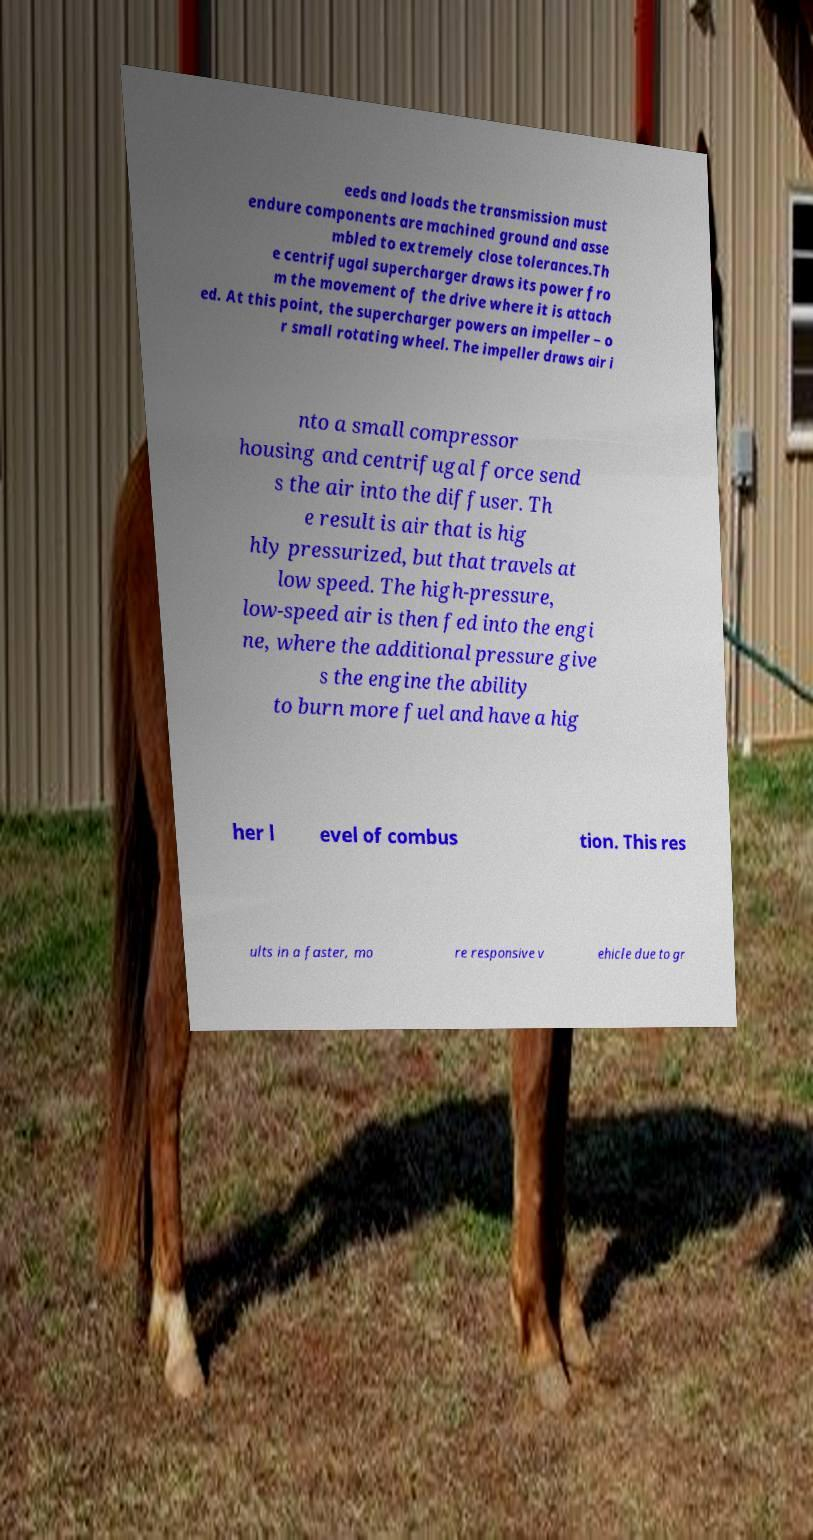Can you accurately transcribe the text from the provided image for me? eeds and loads the transmission must endure components are machined ground and asse mbled to extremely close tolerances.Th e centrifugal supercharger draws its power fro m the movement of the drive where it is attach ed. At this point, the supercharger powers an impeller – o r small rotating wheel. The impeller draws air i nto a small compressor housing and centrifugal force send s the air into the diffuser. Th e result is air that is hig hly pressurized, but that travels at low speed. The high-pressure, low-speed air is then fed into the engi ne, where the additional pressure give s the engine the ability to burn more fuel and have a hig her l evel of combus tion. This res ults in a faster, mo re responsive v ehicle due to gr 